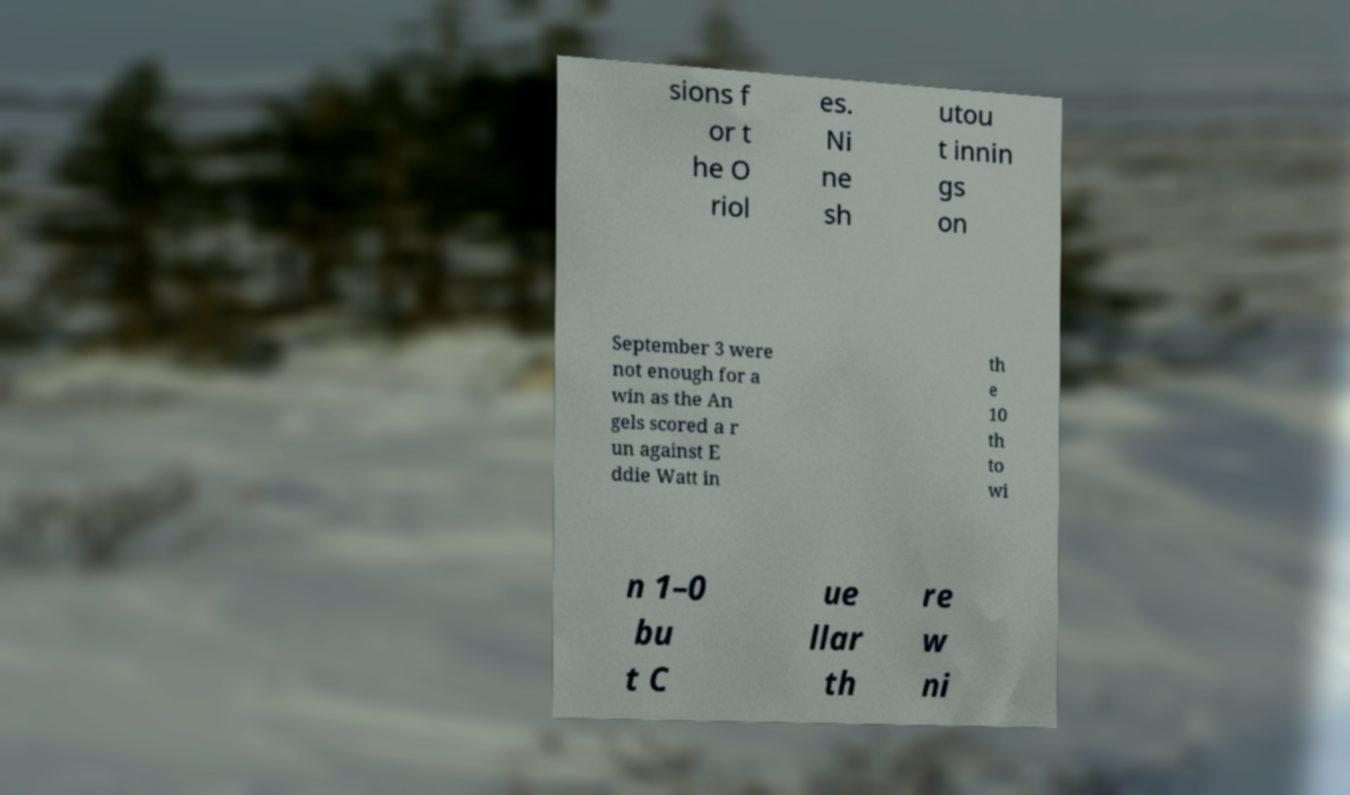Could you extract and type out the text from this image? sions f or t he O riol es. Ni ne sh utou t innin gs on September 3 were not enough for a win as the An gels scored a r un against E ddie Watt in th e 10 th to wi n 1–0 bu t C ue llar th re w ni 